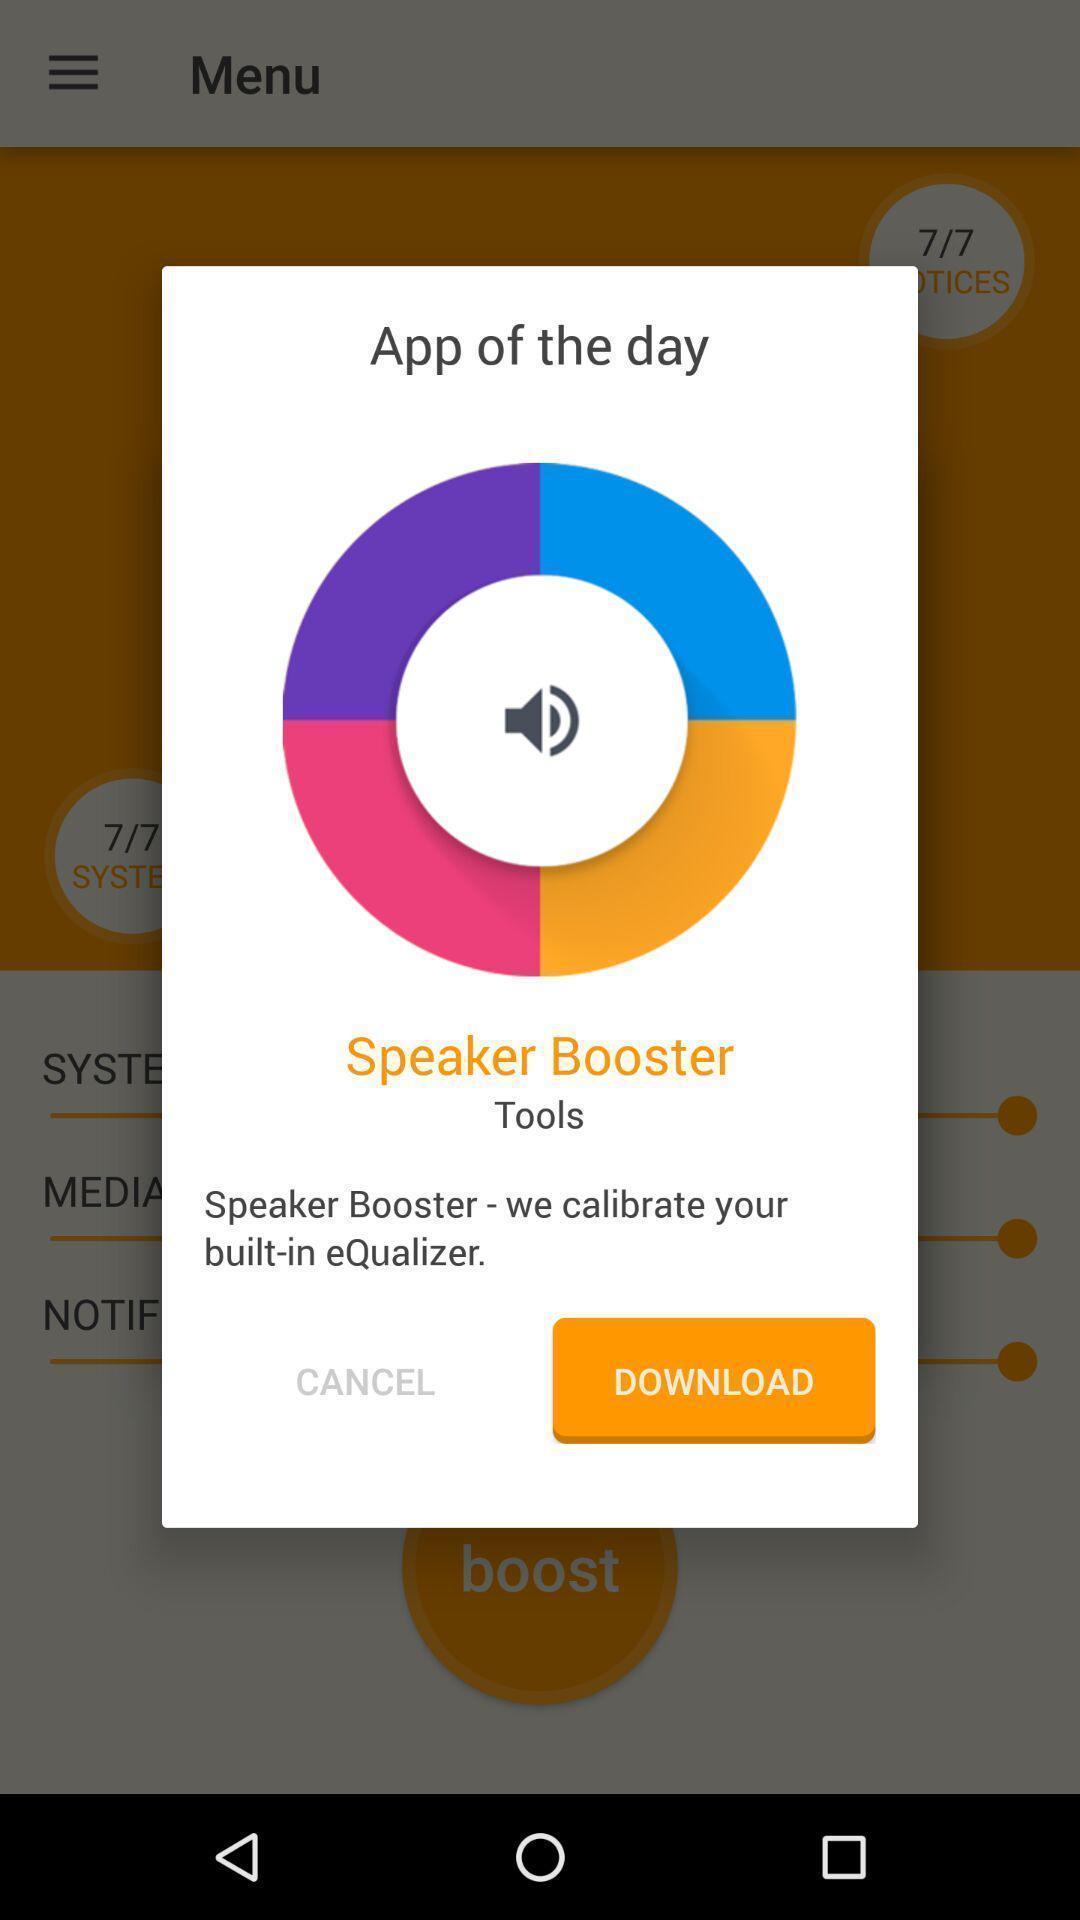Provide a description of this screenshot. Pop-up showing cancel and download options with app info. 